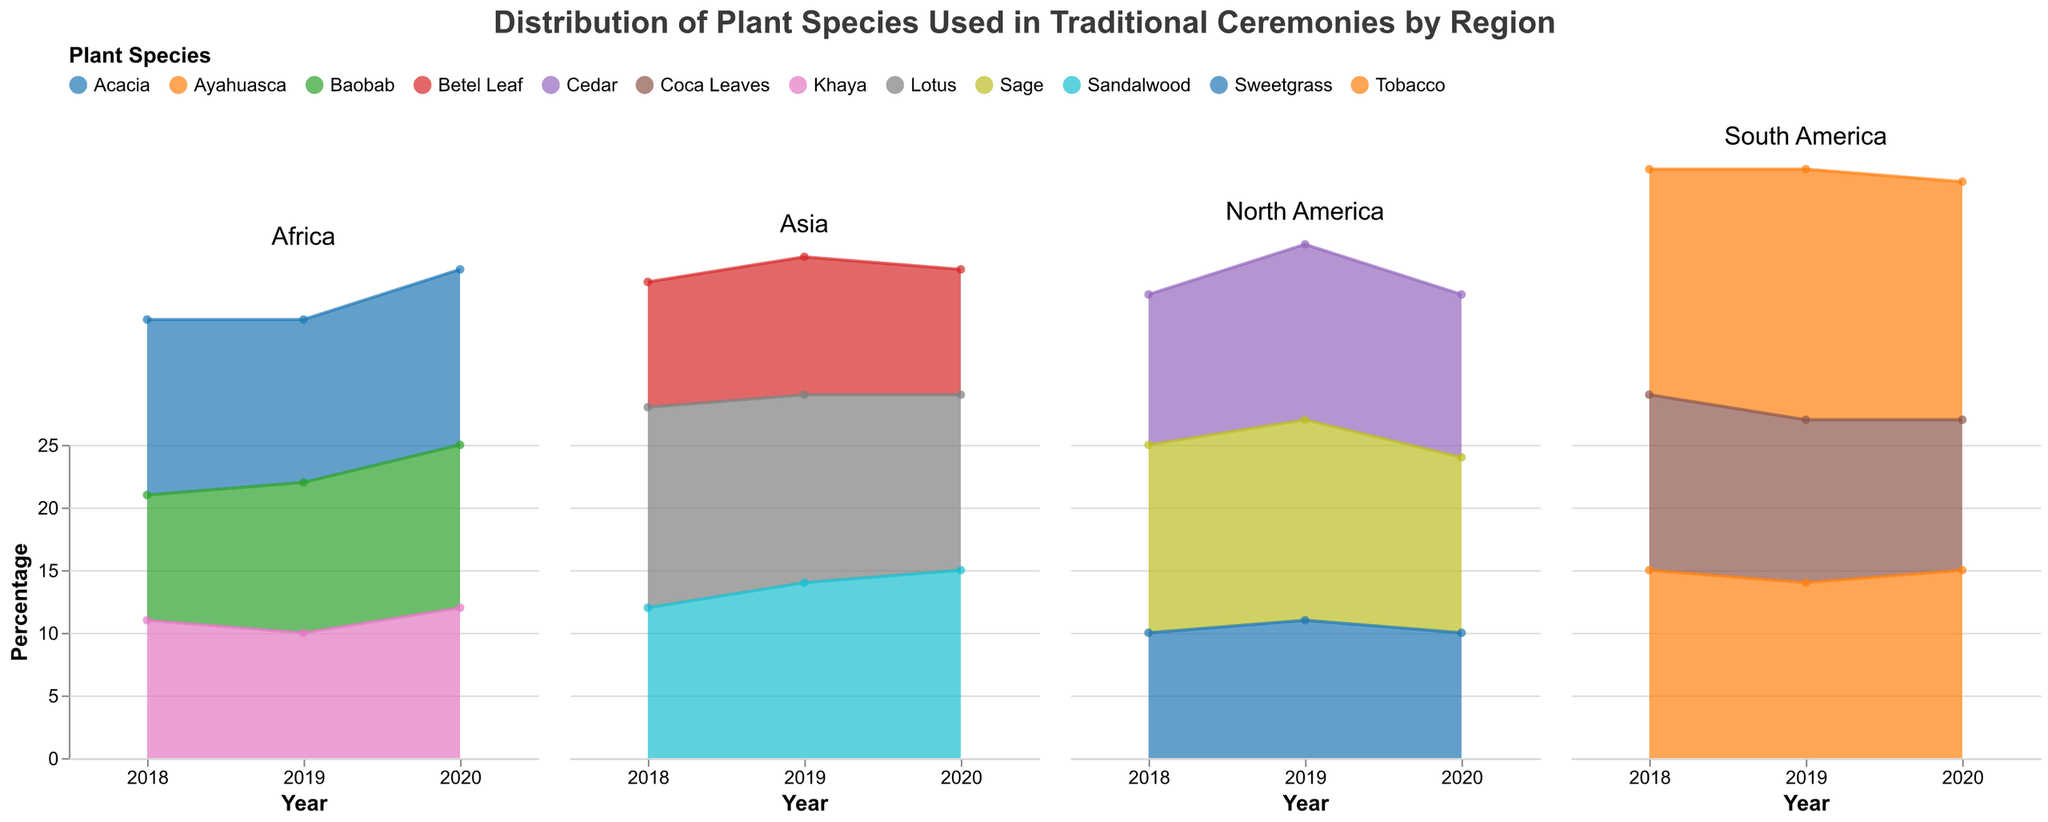What is the title of the figure? The title of the figure is usually prominently displayed at the top. It provides a summary of what the figure depicts.
Answer: Distribution of Plant Species Used in Traditional Ceremonies by Region What color represents the plant species "Sage" in the North America subplot? By observing the legend specific to the North America subplot, we can find the color that indicates which color corresponds to "Sage".
Answer: (Color used in the plot for Sage) Which plant species in South America had the highest percentage in 2020? Look at the South America subplot and identify the plant with the highest area (highest y-value) at the year 2020.
Answer: Ayahuasca How has the percentage of "Khaya" changed from 2018 to 2020 in Africa? By analyzing the Africa subplot and tracing the changes across the years 2018, 2019, and 2020 for "Khaya", we notice a trend in the respective percentages.
Answer: It increased from 11% in 2018 to 12% in 2020, with a slight dip to 10% in 2019 Compare the percentage of "Lotus" in 2018 and 2020 in Asia. Was there an increase or decrease? Check the percentage values for "Lotus" in the Asia subplot at the years 2018 and 2020. Compare these values to determine the trend.
Answer: Decrease Which region showed the greatest stability in plant species percentages over the years? Examine the overall trends in all the subplots and find the subplot where the lines are the flattest, indicating the smallest changes in percentages.
Answer: Africa By how much did the percentage of "Sweetgrass" change in North America from 2018 to 2019? Find the percentage values for "Sweetgrass" in the North America subplot for the years 2018 and 2019, then calculate the difference.
Answer: 1% increase (from 10% to 11%) Is the percentage of "Cedar" in North America in 2020 higher or lower than the percentage of "Tobacco" in South America in 2020? Compare the 2020 percentage values for "Cedar" in North America and "Tobacco" in South America from their respective subplots.
Answer: Lower Which plant species in Asia had the most significant decrease in percentage from 2018 to 2020? Observe the Asia subplot and compare the plant species' percentages in 2018 and 2020. Identify the one with the largest drop.
Answer: Lotus 